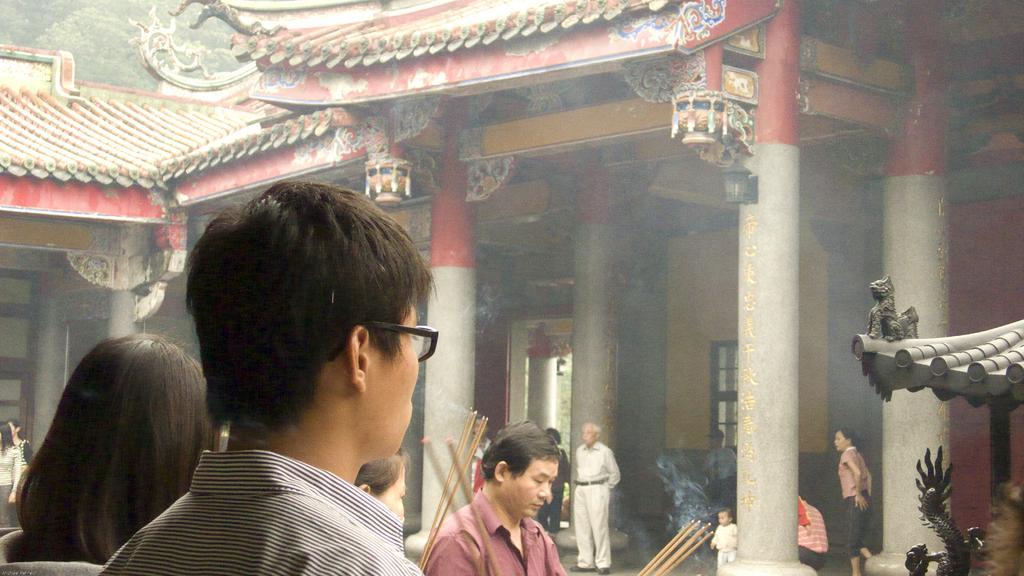In one or two sentences, can you explain what this image depicts? In this image, It looks like a temple with the pillars. I can see few people standing. On the right side of the image, these look like the sculptures. I can see few people holding the incense sticks. 